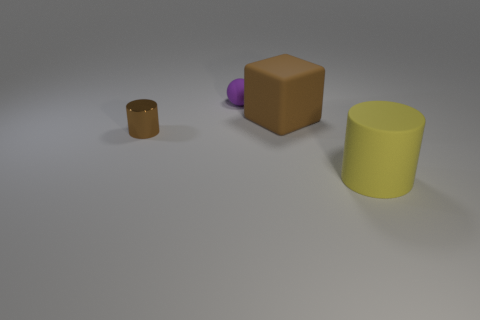There is a brown thing that is right of the small matte sphere; is its shape the same as the small shiny object?
Give a very brief answer. No. What number of big things are gray rubber things or purple objects?
Your answer should be compact. 0. Are there the same number of brown cubes behind the large brown cube and blocks that are behind the purple ball?
Keep it short and to the point. Yes. What number of other things are there of the same color as the sphere?
Keep it short and to the point. 0. Do the rubber cube and the cylinder that is to the right of the small purple rubber thing have the same color?
Your answer should be compact. No. What number of gray objects are metallic cylinders or small objects?
Your answer should be very brief. 0. Are there the same number of cylinders right of the purple thing and tiny purple objects?
Provide a succinct answer. Yes. Is there any other thing that is the same size as the brown rubber cube?
Provide a short and direct response. Yes. What is the color of the small metal object that is the same shape as the big yellow thing?
Provide a succinct answer. Brown. How many shiny things are the same shape as the yellow rubber thing?
Your answer should be compact. 1. 